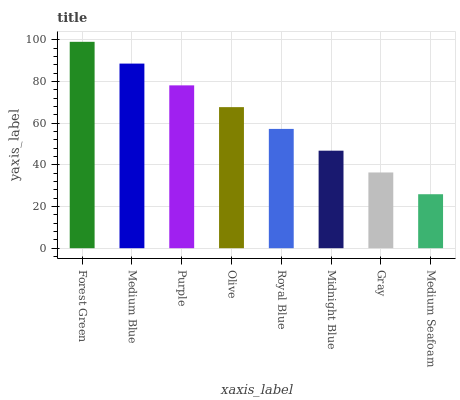Is Medium Seafoam the minimum?
Answer yes or no. Yes. Is Forest Green the maximum?
Answer yes or no. Yes. Is Medium Blue the minimum?
Answer yes or no. No. Is Medium Blue the maximum?
Answer yes or no. No. Is Forest Green greater than Medium Blue?
Answer yes or no. Yes. Is Medium Blue less than Forest Green?
Answer yes or no. Yes. Is Medium Blue greater than Forest Green?
Answer yes or no. No. Is Forest Green less than Medium Blue?
Answer yes or no. No. Is Olive the high median?
Answer yes or no. Yes. Is Royal Blue the low median?
Answer yes or no. Yes. Is Forest Green the high median?
Answer yes or no. No. Is Medium Blue the low median?
Answer yes or no. No. 